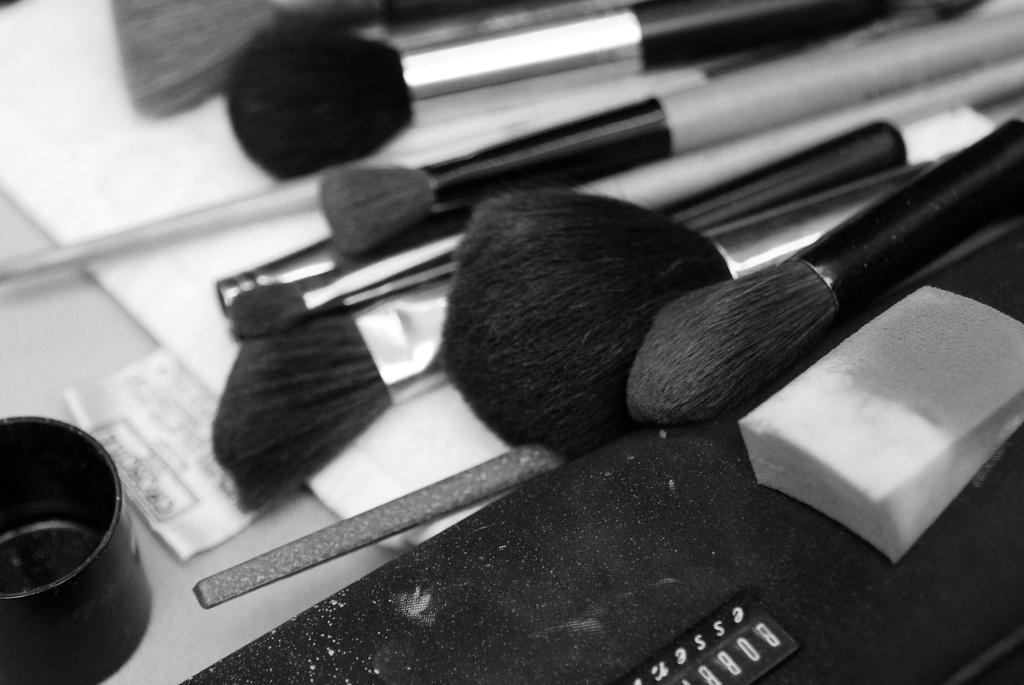Can you describe this image briefly? This is a black and white image. In this image we can see many makeup brushes placed on the table. 